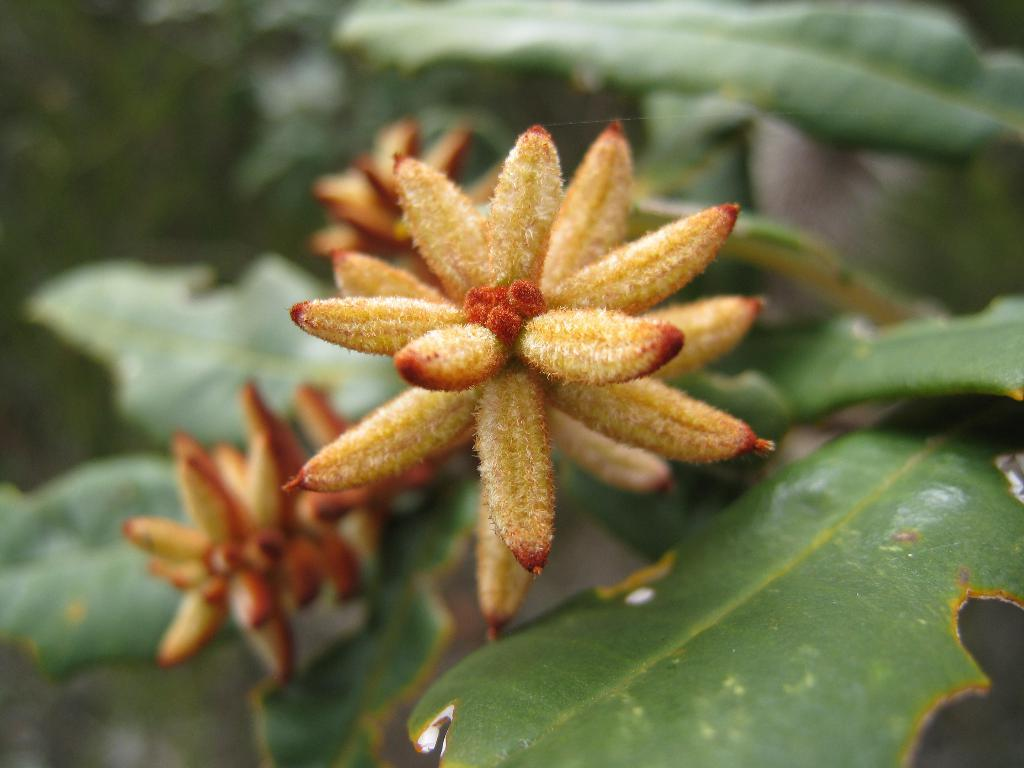What type of plant can be seen in the image? There is a flower and leaves of a plant in the image. Can you describe the flower in the image? Unfortunately, the specific type of flower cannot be determined from the image alone. What else is visible in the image besides the flower and leaves? Based on the provided facts, there is no other information about the image. How much change does the beggar have in the image? There is no beggar or change present in the image; it only features a flower and leaves of a plant. 